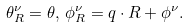Convert formula to latex. <formula><loc_0><loc_0><loc_500><loc_500>\theta _ { R } ^ { \nu } = \theta , \, \phi _ { R } ^ { \nu } = { q \cdot R } + \phi ^ { \nu } .</formula> 